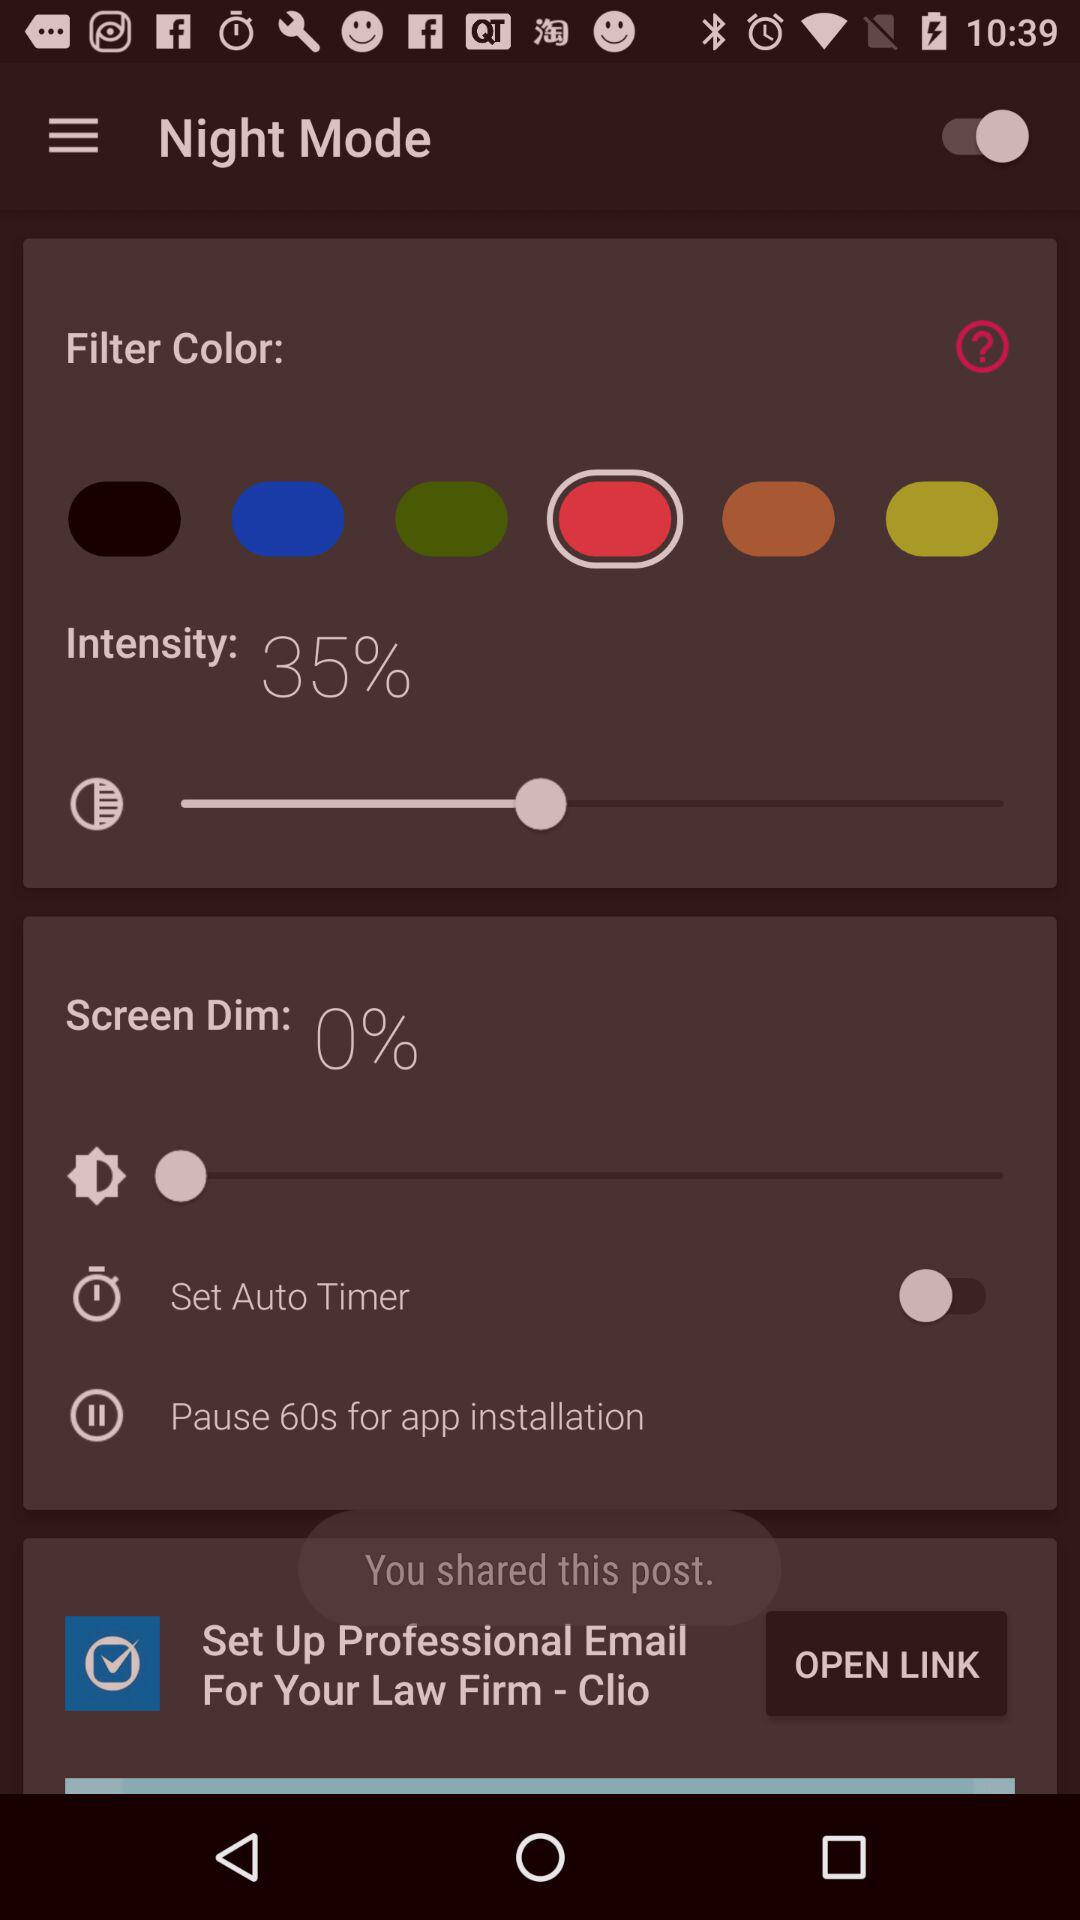What is the percentage of intensity? The percentage of intensity is 35. 